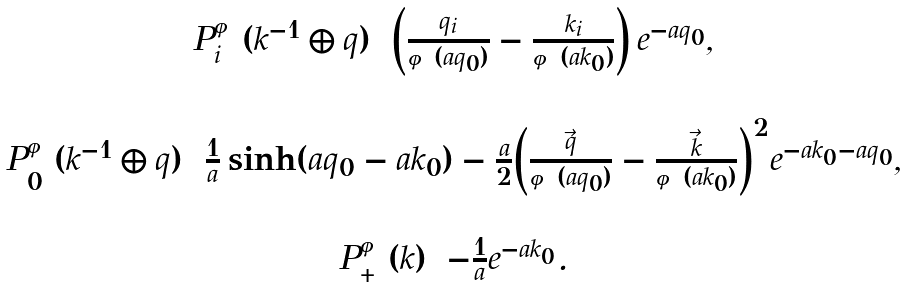<formula> <loc_0><loc_0><loc_500><loc_500>\begin{array} { c } P _ { i } ^ { \varphi } ( k ^ { - 1 } \oplus q ) = \left ( \frac { q _ { i } } { \varphi ( a q _ { 0 } ) } - \frac { k _ { i } } { \varphi ( a k _ { 0 } ) } \right ) e ^ { - a q _ { 0 } } , \\ \\ P _ { 0 } ^ { \varphi } ( k ^ { - 1 } \oplus q ) = \frac { 1 } { a } \sinh ( a q _ { 0 } - a k _ { 0 } ) - \frac { a } { 2 } { \left ( \frac { \vec { q } } { \varphi ( a q _ { 0 } ) } - \frac { \vec { k } } { \varphi ( a k _ { 0 } ) } \right ) } ^ { 2 } e ^ { - a k _ { 0 } - a q _ { 0 } } , \\ \\ P _ { + } ^ { \varphi } ( k ) = - \frac { 1 } { a } e ^ { - a k _ { 0 } } . \end{array}</formula> 